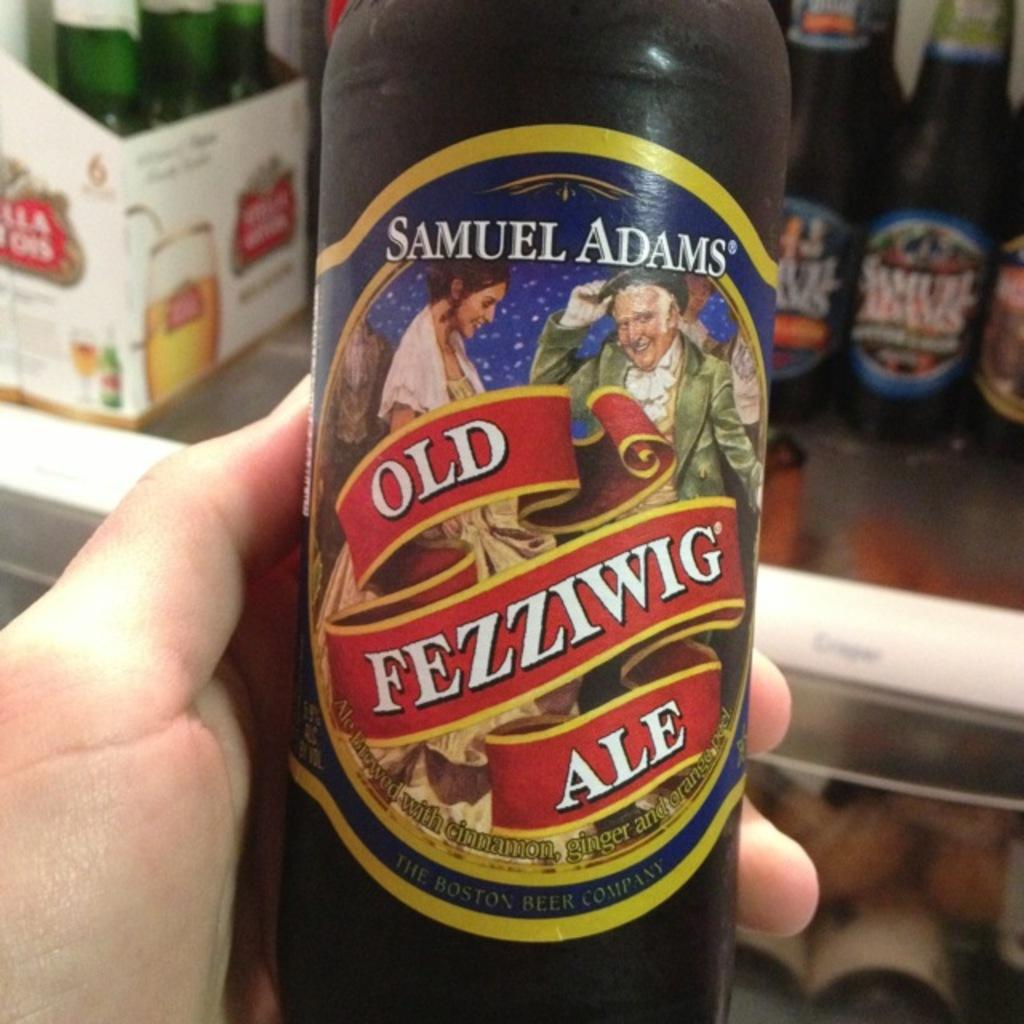What is the human holding in the image? The human is holding a bottle in the image. What can be seen on the bottle? There is a sticker on the bottle. What else can be seen in the background of the image? There are bottles in the background of the image. What is located on the left side of the image? There is a cotton box on the left side of the image. What language is the bear speaking in the image? There is no bear present in the image, so it is not possible to determine the language being spoken. 